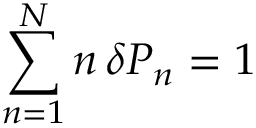<formula> <loc_0><loc_0><loc_500><loc_500>\sum _ { n = 1 } ^ { N } n \, \delta P _ { n } = 1</formula> 